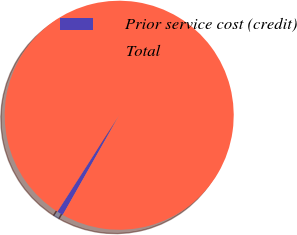<chart> <loc_0><loc_0><loc_500><loc_500><pie_chart><fcel>Prior service cost (credit)<fcel>Total<nl><fcel>0.87%<fcel>99.13%<nl></chart> 